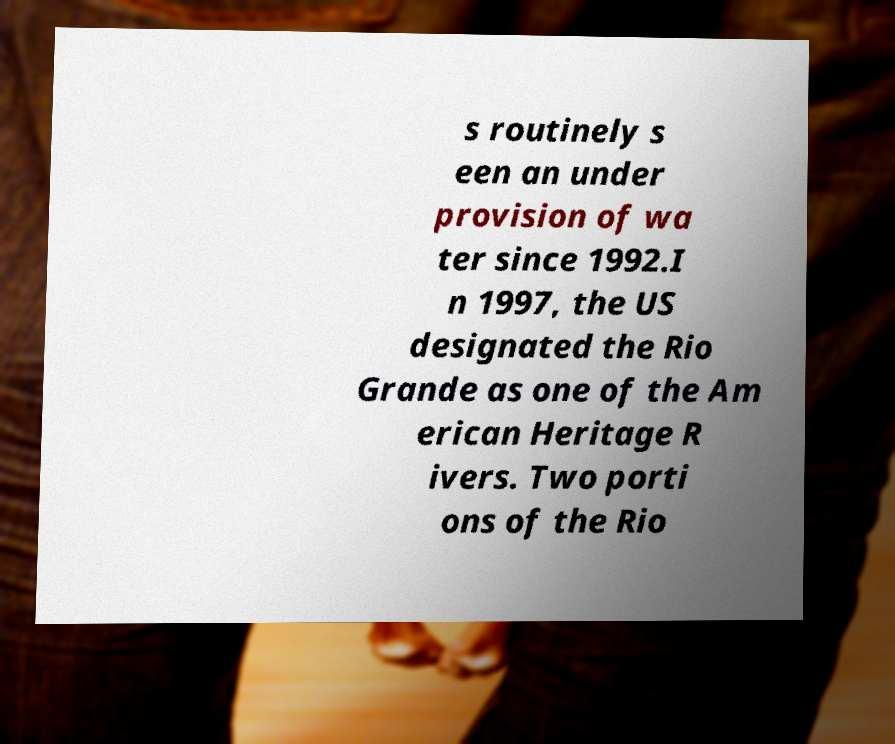I need the written content from this picture converted into text. Can you do that? s routinely s een an under provision of wa ter since 1992.I n 1997, the US designated the Rio Grande as one of the Am erican Heritage R ivers. Two porti ons of the Rio 